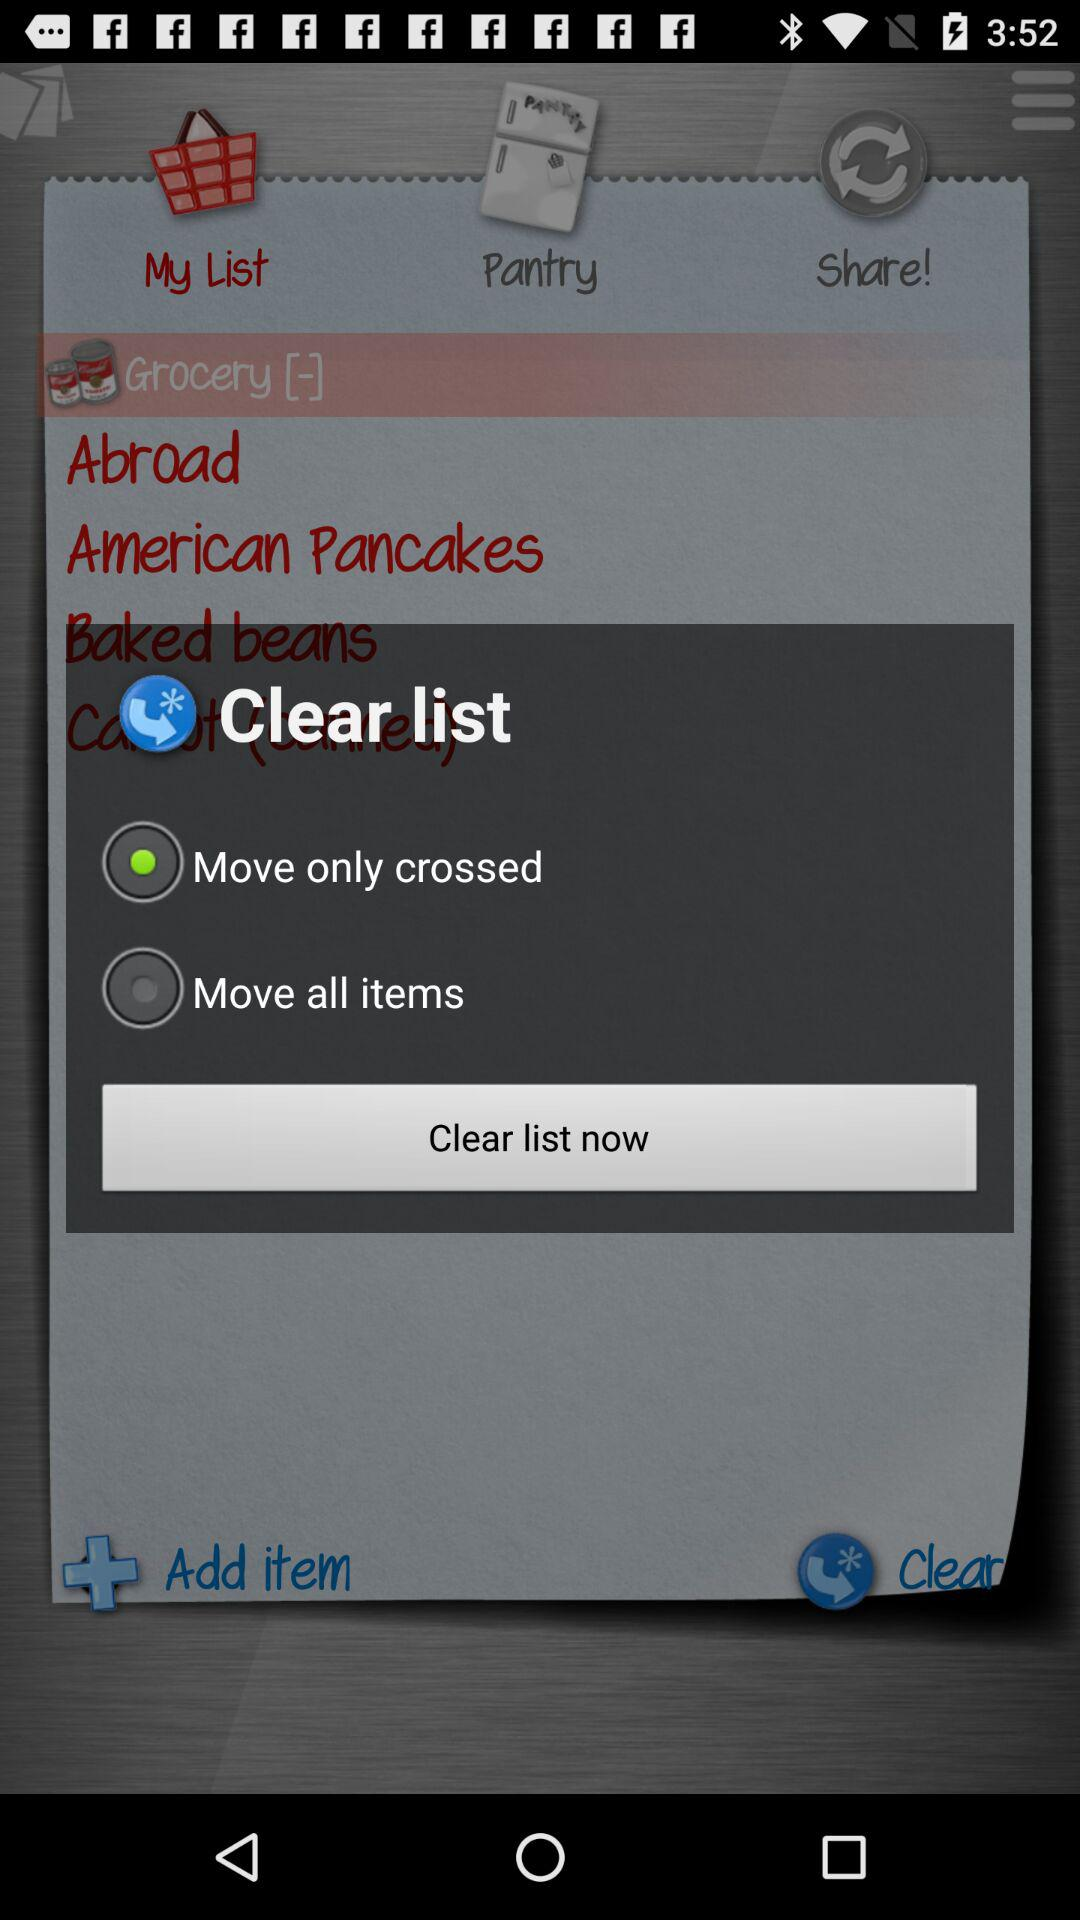What option has been selected? The selected option is "Move only crossed". 